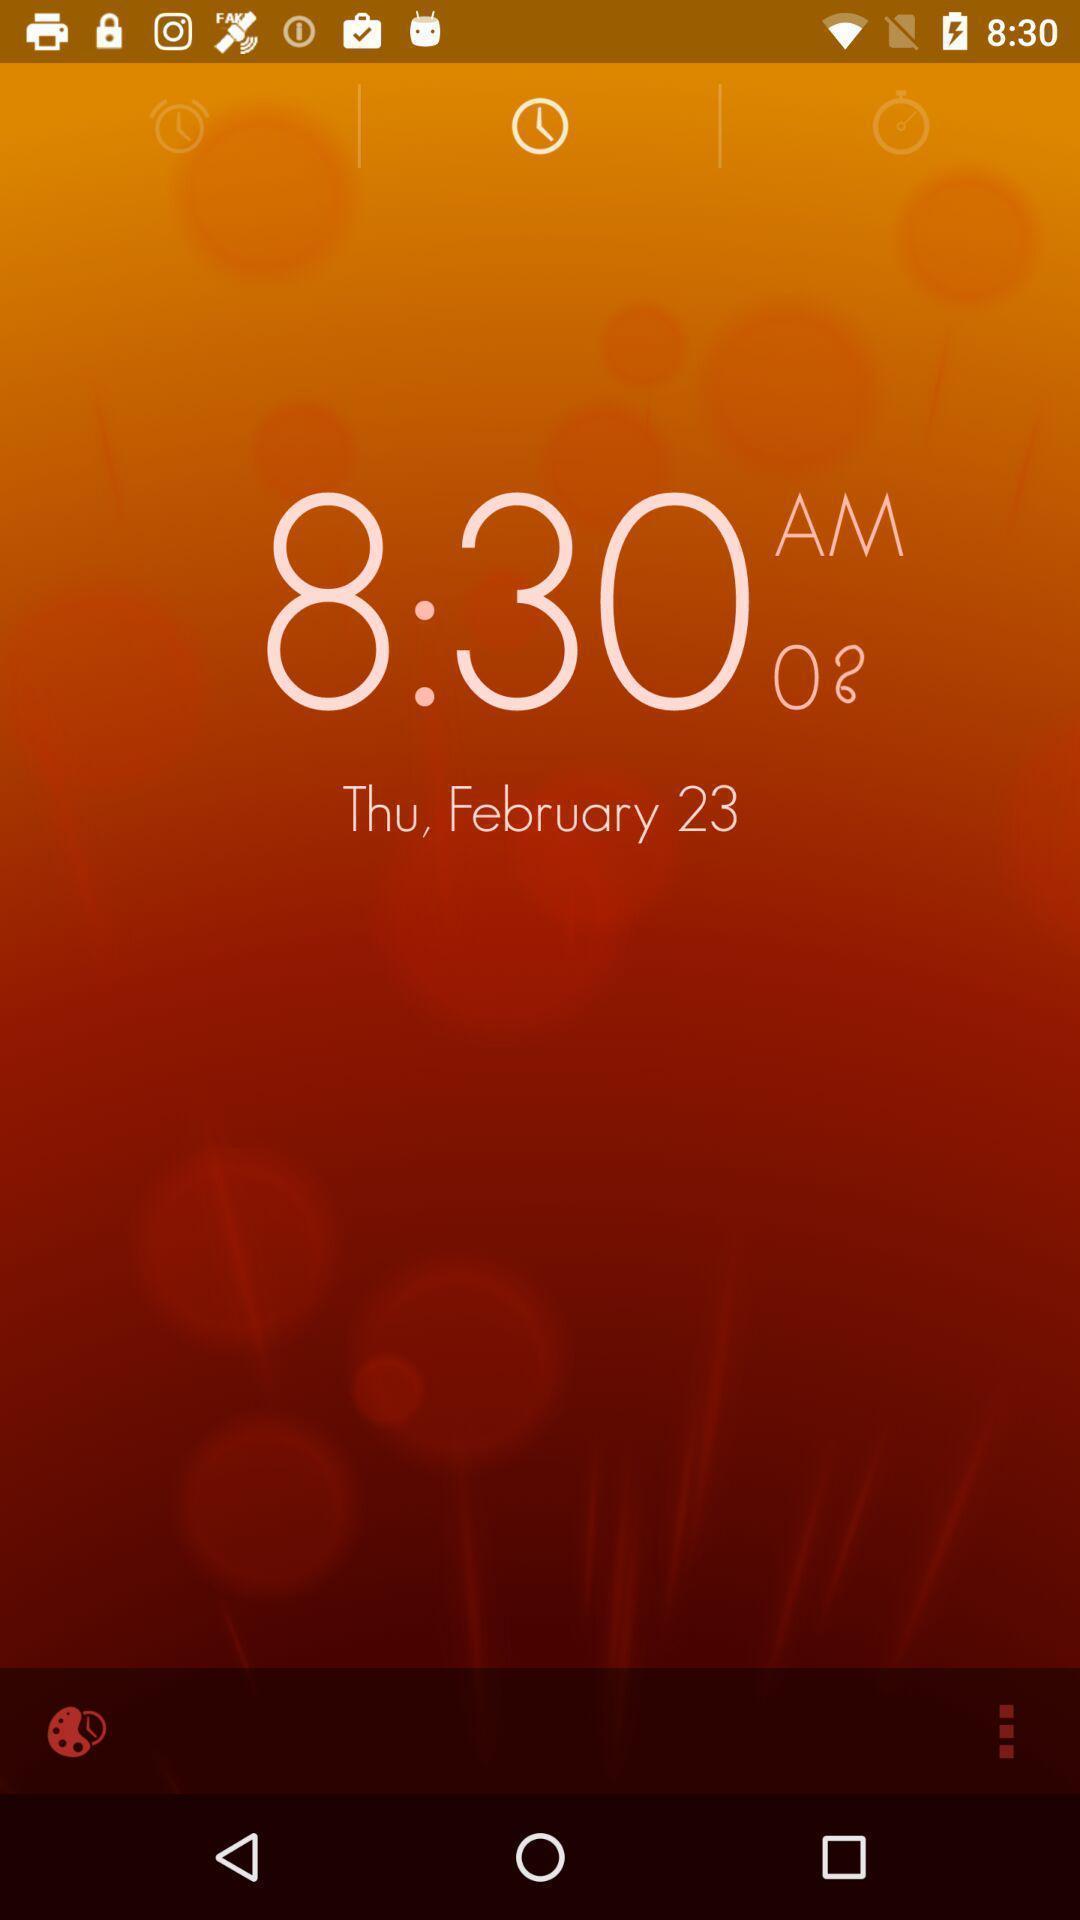Please provide a description for this image. Page showing alarm clock. 